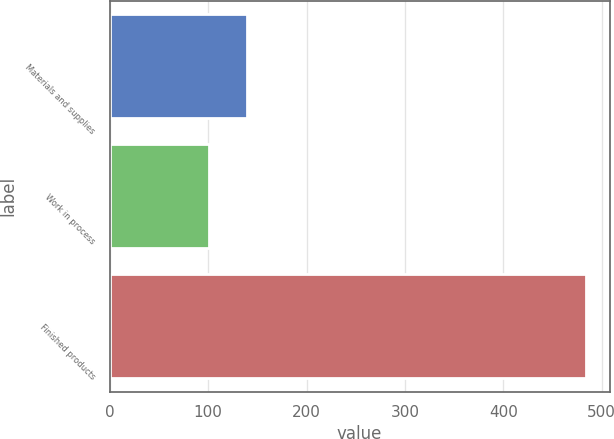<chart> <loc_0><loc_0><loc_500><loc_500><bar_chart><fcel>Materials and supplies<fcel>Work in process<fcel>Finished products<nl><fcel>139.28<fcel>101<fcel>483.8<nl></chart> 